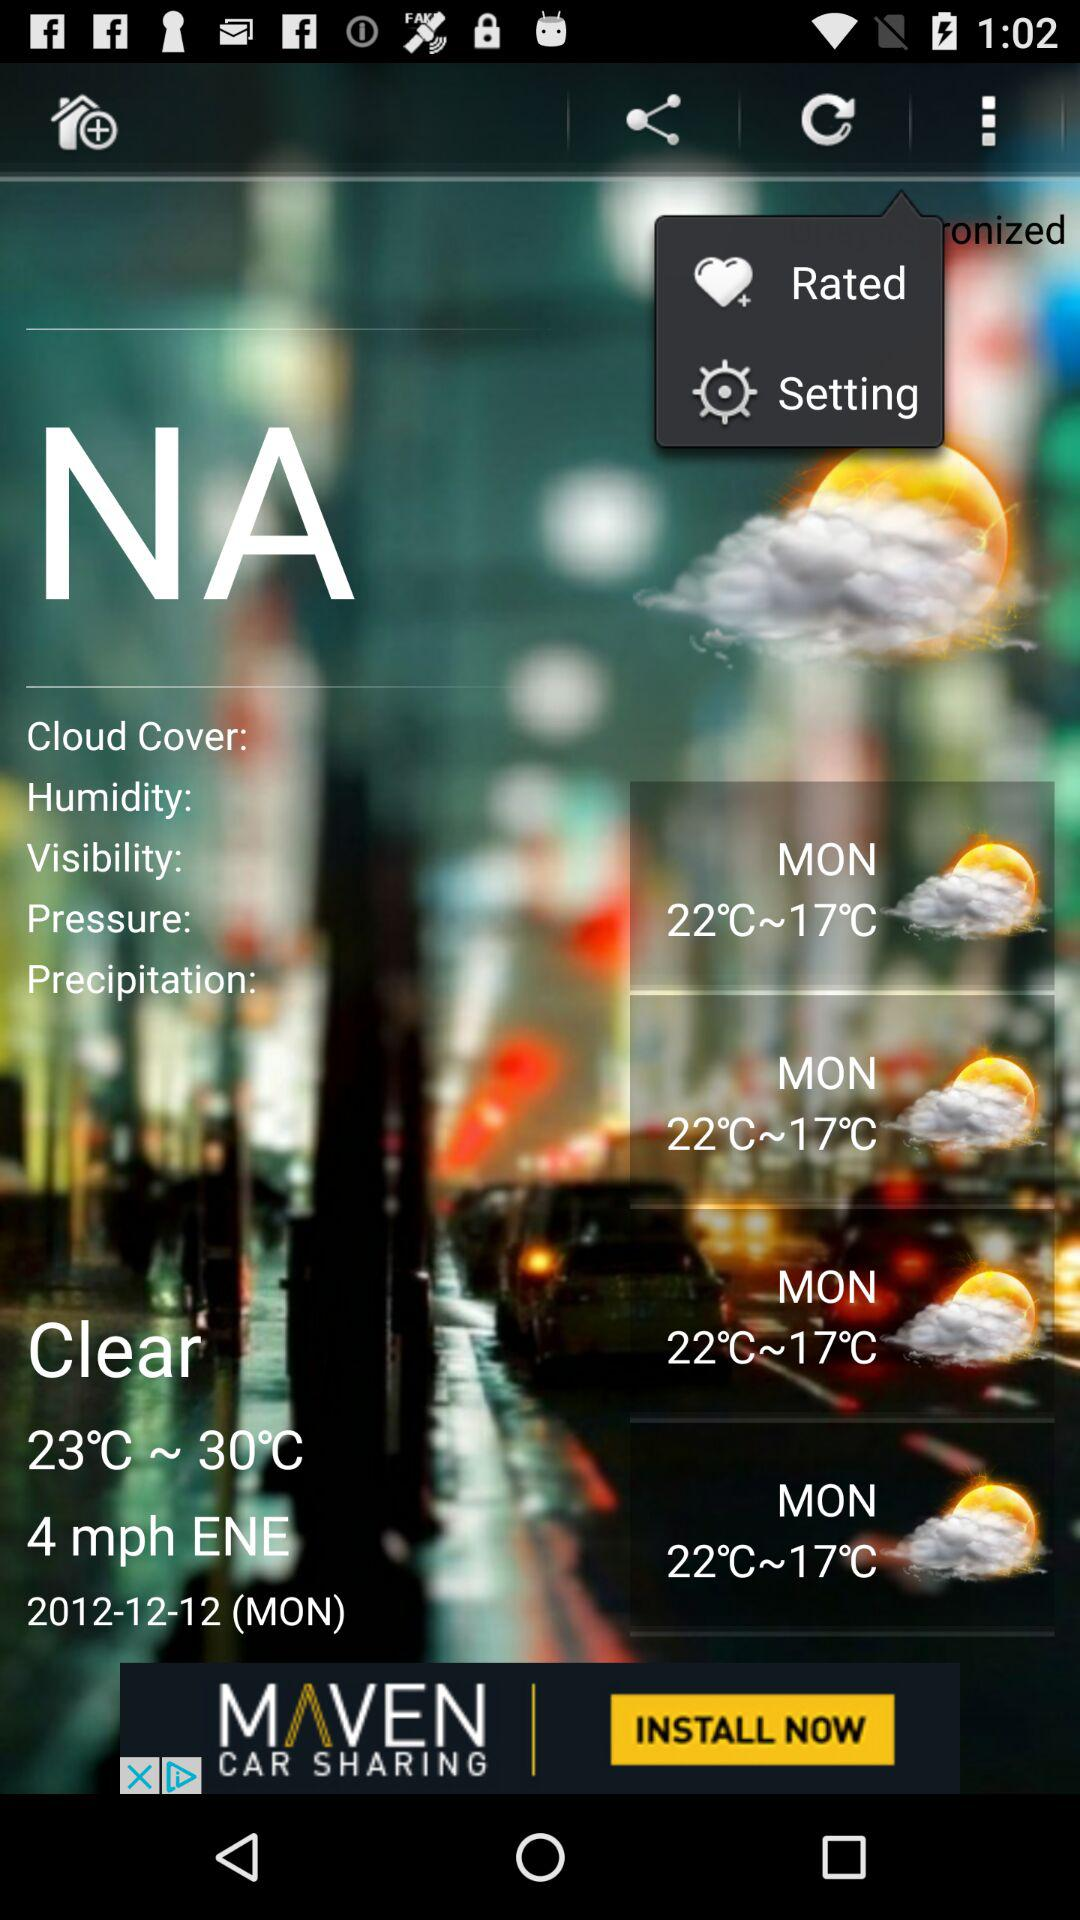What is the temperature on Monday? The temperature on Monday ranges from 17 °C to 22 °C. 